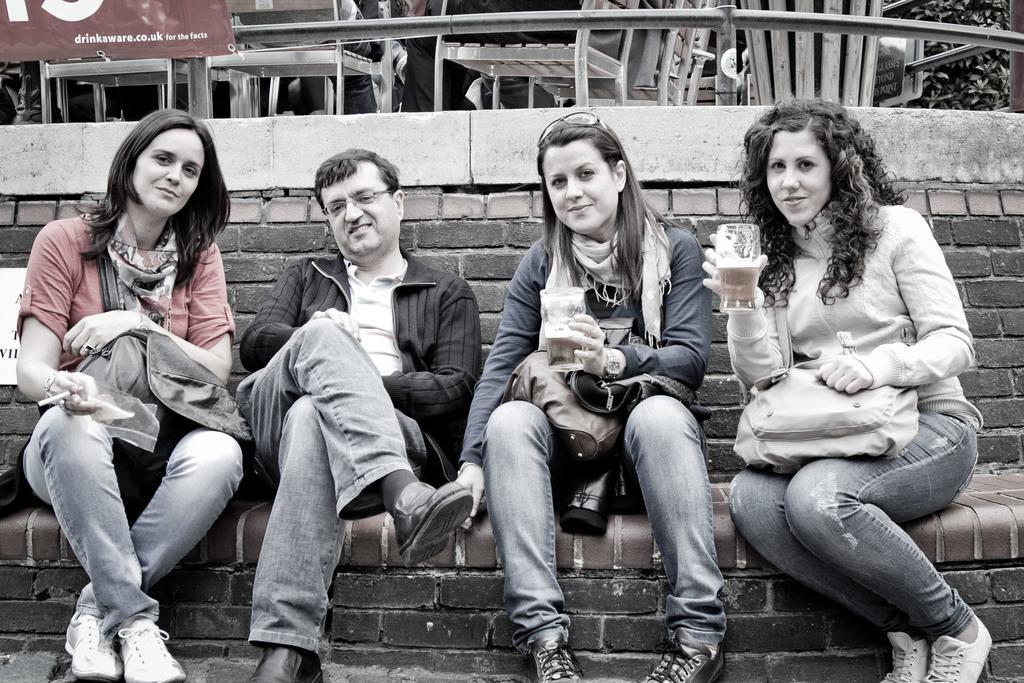Please provide a concise description of this image. In this image, we can see four people are sitting and smiling. Few are holding some objects and wearing glasses. Background we can see a brick wall. Top of the image, we can see few chairs, rod, banner, plants, boards. Here we can see few human legs. 